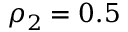Convert formula to latex. <formula><loc_0><loc_0><loc_500><loc_500>\rho _ { 2 } = 0 . 5</formula> 